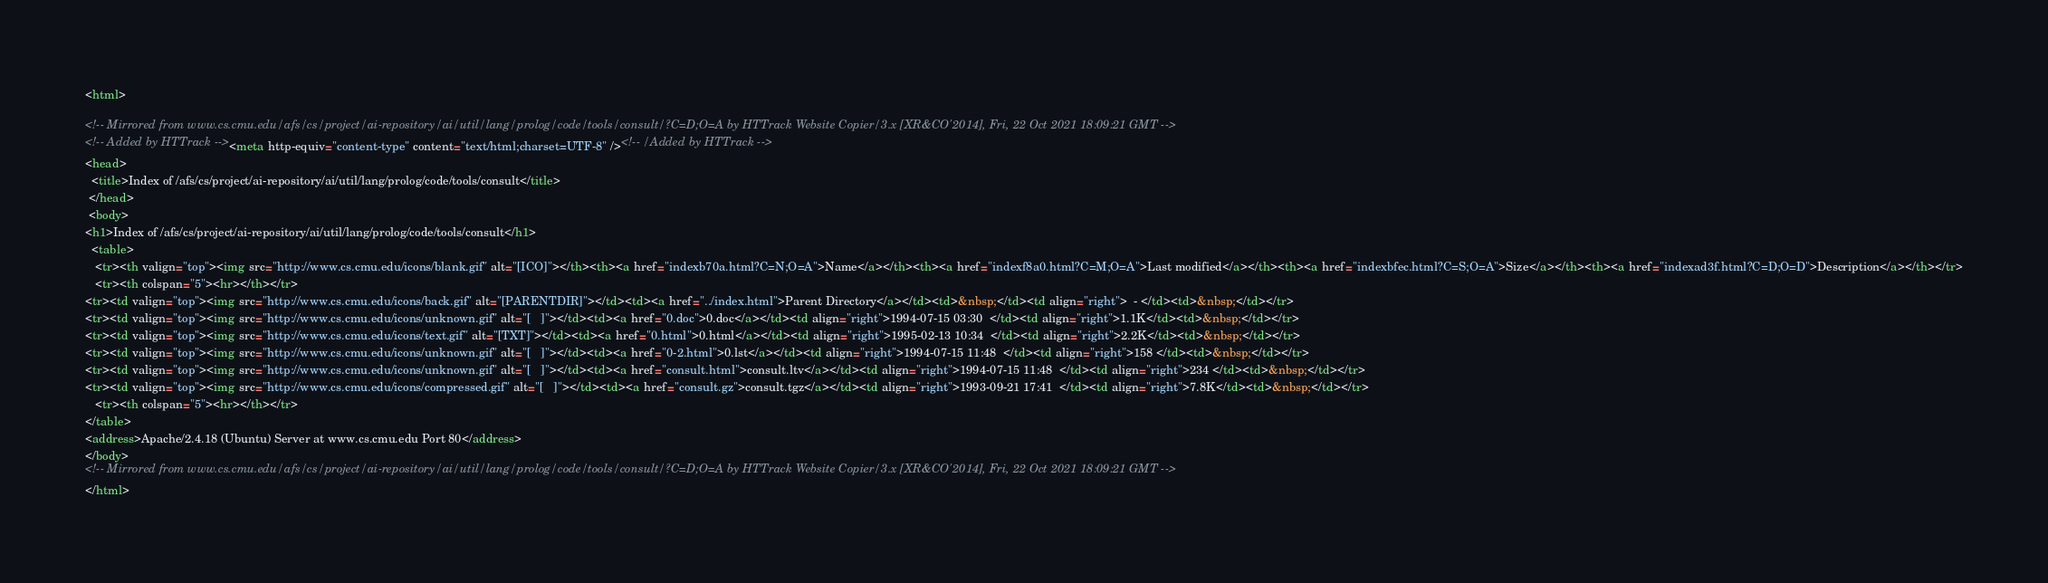<code> <loc_0><loc_0><loc_500><loc_500><_HTML_><html>
 
<!-- Mirrored from www.cs.cmu.edu/afs/cs/project/ai-repository/ai/util/lang/prolog/code/tools/consult/?C=D;O=A by HTTrack Website Copier/3.x [XR&CO'2014], Fri, 22 Oct 2021 18:09:21 GMT -->
<!-- Added by HTTrack --><meta http-equiv="content-type" content="text/html;charset=UTF-8" /><!-- /Added by HTTrack -->
<head>
  <title>Index of /afs/cs/project/ai-repository/ai/util/lang/prolog/code/tools/consult</title>
 </head>
 <body>
<h1>Index of /afs/cs/project/ai-repository/ai/util/lang/prolog/code/tools/consult</h1>
  <table>
   <tr><th valign="top"><img src="http://www.cs.cmu.edu/icons/blank.gif" alt="[ICO]"></th><th><a href="indexb70a.html?C=N;O=A">Name</a></th><th><a href="indexf8a0.html?C=M;O=A">Last modified</a></th><th><a href="indexbfec.html?C=S;O=A">Size</a></th><th><a href="indexad3f.html?C=D;O=D">Description</a></th></tr>
   <tr><th colspan="5"><hr></th></tr>
<tr><td valign="top"><img src="http://www.cs.cmu.edu/icons/back.gif" alt="[PARENTDIR]"></td><td><a href="../index.html">Parent Directory</a></td><td>&nbsp;</td><td align="right">  - </td><td>&nbsp;</td></tr>
<tr><td valign="top"><img src="http://www.cs.cmu.edu/icons/unknown.gif" alt="[   ]"></td><td><a href="0.doc">0.doc</a></td><td align="right">1994-07-15 03:30  </td><td align="right">1.1K</td><td>&nbsp;</td></tr>
<tr><td valign="top"><img src="http://www.cs.cmu.edu/icons/text.gif" alt="[TXT]"></td><td><a href="0.html">0.html</a></td><td align="right">1995-02-13 10:34  </td><td align="right">2.2K</td><td>&nbsp;</td></tr>
<tr><td valign="top"><img src="http://www.cs.cmu.edu/icons/unknown.gif" alt="[   ]"></td><td><a href="0-2.html">0.lst</a></td><td align="right">1994-07-15 11:48  </td><td align="right">158 </td><td>&nbsp;</td></tr>
<tr><td valign="top"><img src="http://www.cs.cmu.edu/icons/unknown.gif" alt="[   ]"></td><td><a href="consult.html">consult.ltv</a></td><td align="right">1994-07-15 11:48  </td><td align="right">234 </td><td>&nbsp;</td></tr>
<tr><td valign="top"><img src="http://www.cs.cmu.edu/icons/compressed.gif" alt="[   ]"></td><td><a href="consult.gz">consult.tgz</a></td><td align="right">1993-09-21 17:41  </td><td align="right">7.8K</td><td>&nbsp;</td></tr>
   <tr><th colspan="5"><hr></th></tr>
</table>
<address>Apache/2.4.18 (Ubuntu) Server at www.cs.cmu.edu Port 80</address>
</body>
<!-- Mirrored from www.cs.cmu.edu/afs/cs/project/ai-repository/ai/util/lang/prolog/code/tools/consult/?C=D;O=A by HTTrack Website Copier/3.x [XR&CO'2014], Fri, 22 Oct 2021 18:09:21 GMT -->
</html>
</code> 